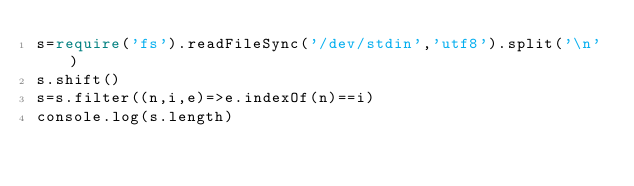Convert code to text. <code><loc_0><loc_0><loc_500><loc_500><_TypeScript_>s=require('fs').readFileSync('/dev/stdin','utf8').split('\n')
s.shift()
s=s.filter((n,i,e)=>e.indexOf(n)==i)
console.log(s.length)</code> 